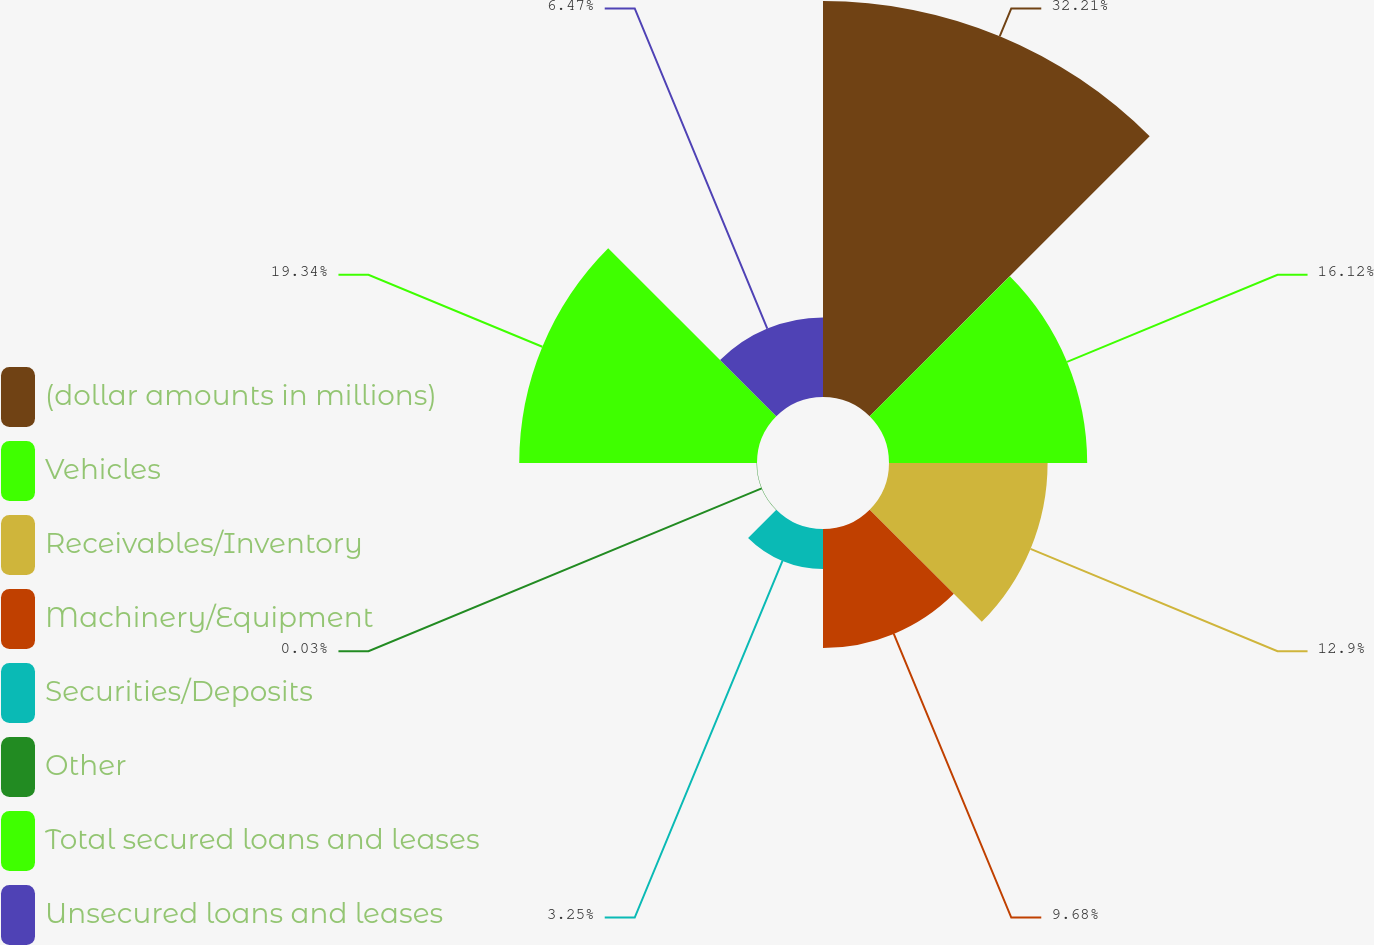<chart> <loc_0><loc_0><loc_500><loc_500><pie_chart><fcel>(dollar amounts in millions)<fcel>Vehicles<fcel>Receivables/Inventory<fcel>Machinery/Equipment<fcel>Securities/Deposits<fcel>Other<fcel>Total secured loans and leases<fcel>Unsecured loans and leases<nl><fcel>32.21%<fcel>16.12%<fcel>12.9%<fcel>9.68%<fcel>3.25%<fcel>0.03%<fcel>19.34%<fcel>6.47%<nl></chart> 